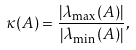Convert formula to latex. <formula><loc_0><loc_0><loc_500><loc_500>\kappa ( A ) = { \frac { \left | \lambda _ { \max } ( A ) \right | } { \left | \lambda _ { \min } ( A ) \right | } } ,</formula> 